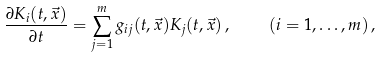Convert formula to latex. <formula><loc_0><loc_0><loc_500><loc_500>\frac { \partial { K } _ { i } ( t , \vec { x } ) } { \partial t } = \sum _ { j = 1 } ^ { m } g _ { i j } ( t , \vec { x } ) { K } _ { j } ( t , \vec { x } ) \, , \quad ( i = 1 , \dots , m ) \, ,</formula> 